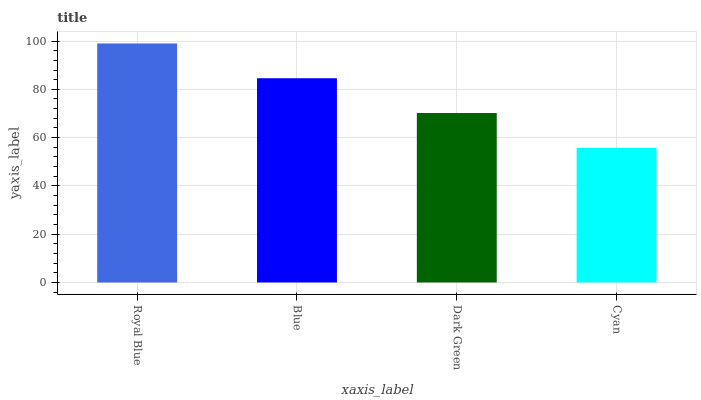Is Cyan the minimum?
Answer yes or no. Yes. Is Royal Blue the maximum?
Answer yes or no. Yes. Is Blue the minimum?
Answer yes or no. No. Is Blue the maximum?
Answer yes or no. No. Is Royal Blue greater than Blue?
Answer yes or no. Yes. Is Blue less than Royal Blue?
Answer yes or no. Yes. Is Blue greater than Royal Blue?
Answer yes or no. No. Is Royal Blue less than Blue?
Answer yes or no. No. Is Blue the high median?
Answer yes or no. Yes. Is Dark Green the low median?
Answer yes or no. Yes. Is Dark Green the high median?
Answer yes or no. No. Is Cyan the low median?
Answer yes or no. No. 